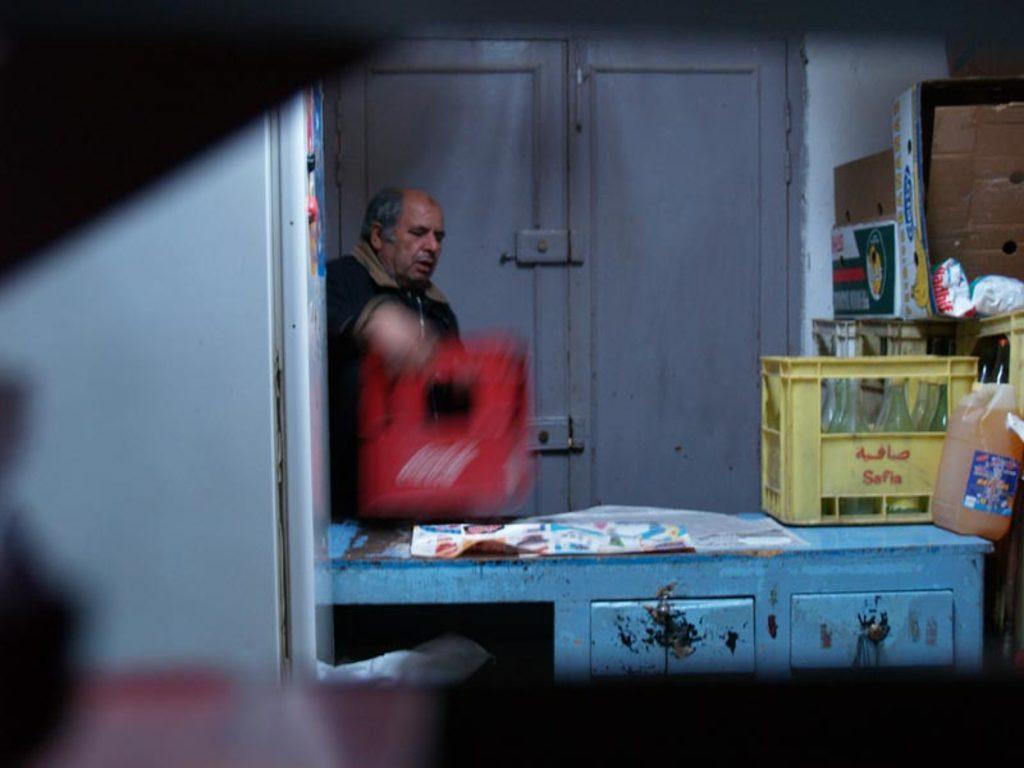Can you describe this image briefly? A man is standing, these are bottles. 